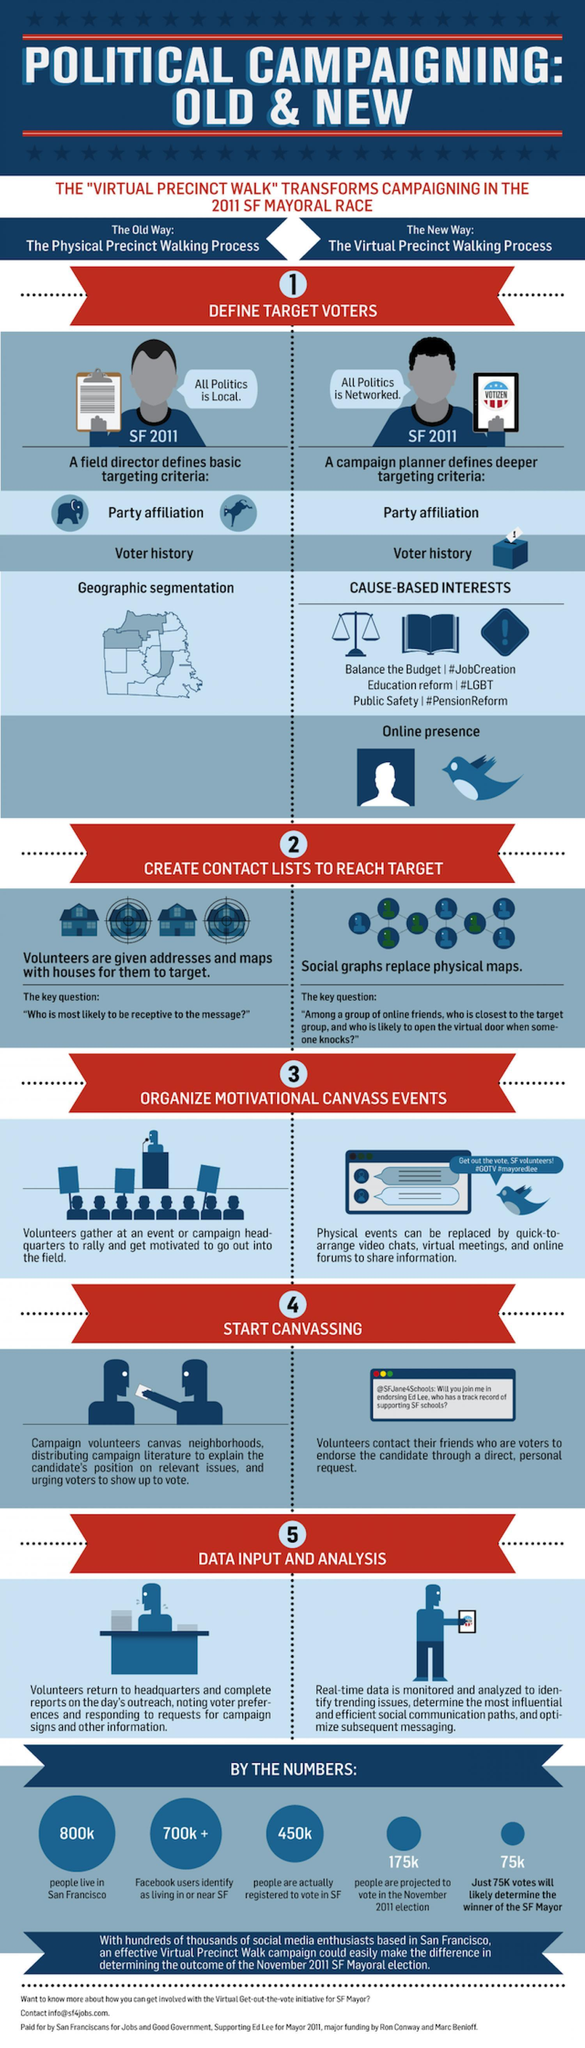What is the population of San Francisco
Answer the question with a short phrase. 800k How is contact lists created in old way volunteers are given addresses and maps with houses for them to target what is the new way called the virtual precinct walking process How is the voter history captured in the new way Cause-based interests How is the voter history captured in the old way geographic segmentation What is the Old way called the physical precinct walking process How is canvassing started in the new way volunteers contact their friends who are voters to endorse the candidate through a direct, personal request How many FB users identify as living in or near SF 700K + 